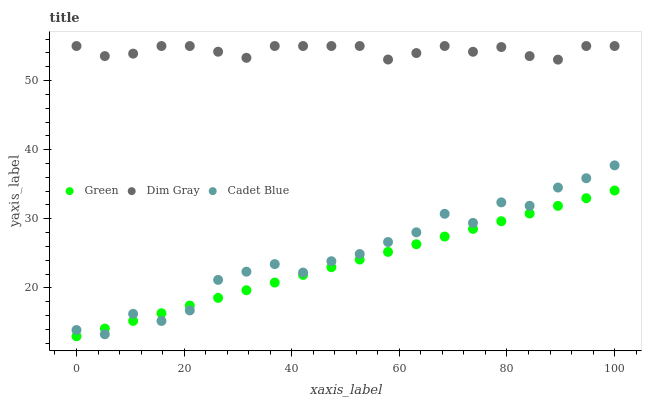Does Green have the minimum area under the curve?
Answer yes or no. Yes. Does Dim Gray have the maximum area under the curve?
Answer yes or no. Yes. Does Dim Gray have the minimum area under the curve?
Answer yes or no. No. Does Green have the maximum area under the curve?
Answer yes or no. No. Is Green the smoothest?
Answer yes or no. Yes. Is Cadet Blue the roughest?
Answer yes or no. Yes. Is Dim Gray the smoothest?
Answer yes or no. No. Is Dim Gray the roughest?
Answer yes or no. No. Does Green have the lowest value?
Answer yes or no. Yes. Does Dim Gray have the lowest value?
Answer yes or no. No. Does Dim Gray have the highest value?
Answer yes or no. Yes. Does Green have the highest value?
Answer yes or no. No. Is Green less than Dim Gray?
Answer yes or no. Yes. Is Dim Gray greater than Green?
Answer yes or no. Yes. Does Green intersect Cadet Blue?
Answer yes or no. Yes. Is Green less than Cadet Blue?
Answer yes or no. No. Is Green greater than Cadet Blue?
Answer yes or no. No. Does Green intersect Dim Gray?
Answer yes or no. No. 